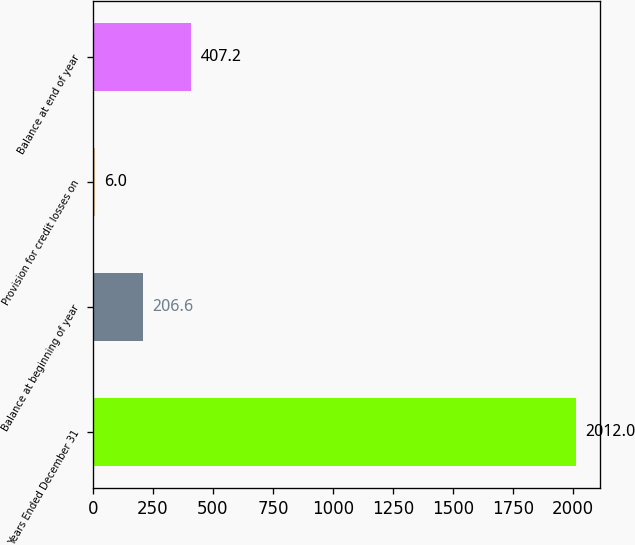Convert chart. <chart><loc_0><loc_0><loc_500><loc_500><bar_chart><fcel>Years Ended December 31<fcel>Balance at beginning of year<fcel>Provision for credit losses on<fcel>Balance at end of year<nl><fcel>2012<fcel>206.6<fcel>6<fcel>407.2<nl></chart> 